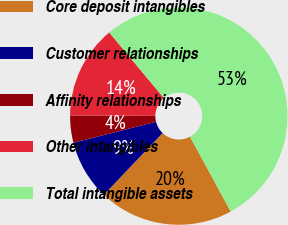<chart> <loc_0><loc_0><loc_500><loc_500><pie_chart><fcel>Core deposit intangibles<fcel>Customer relationships<fcel>Affinity relationships<fcel>Other intangibles<fcel>Total intangible assets<nl><fcel>20.03%<fcel>8.95%<fcel>4.04%<fcel>13.86%<fcel>53.12%<nl></chart> 